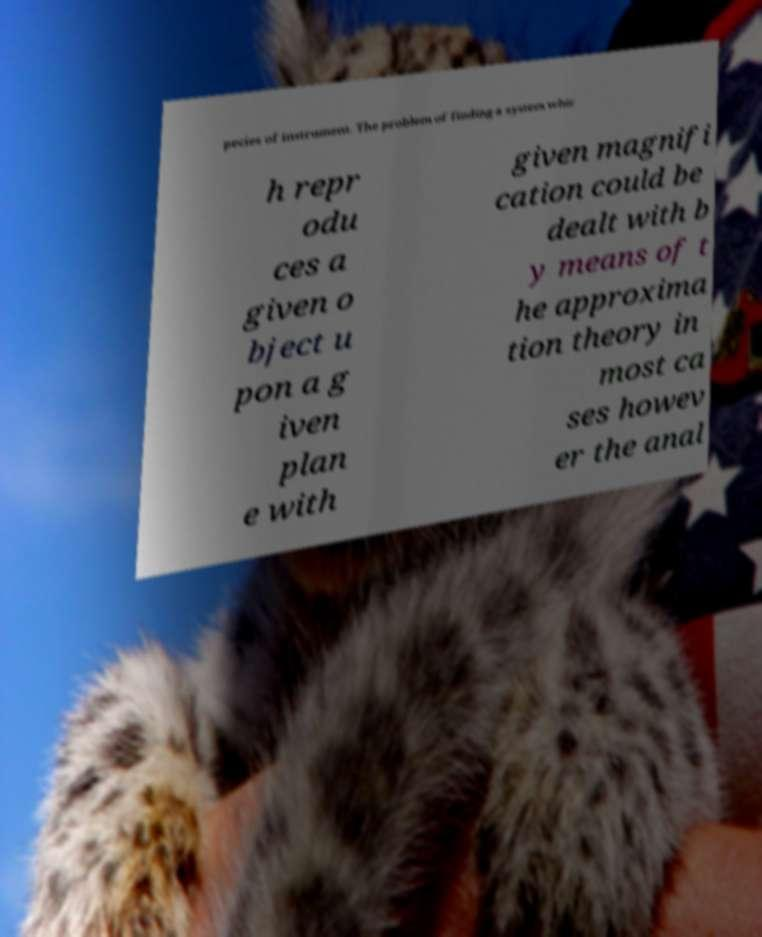Please identify and transcribe the text found in this image. pecies of instrument. The problem of finding a system whic h repr odu ces a given o bject u pon a g iven plan e with given magnifi cation could be dealt with b y means of t he approxima tion theory in most ca ses howev er the anal 